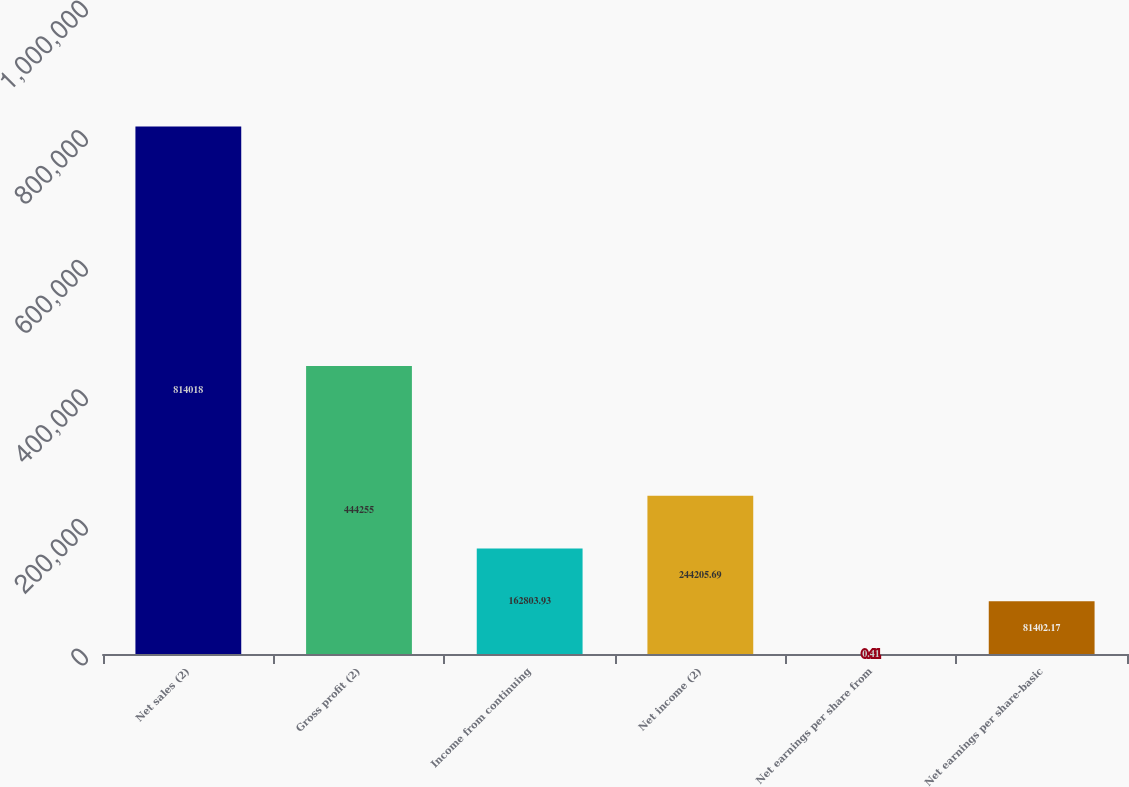Convert chart. <chart><loc_0><loc_0><loc_500><loc_500><bar_chart><fcel>Net sales (2)<fcel>Gross profit (2)<fcel>Income from continuing<fcel>Net income (2)<fcel>Net earnings per share from<fcel>Net earnings per share-basic<nl><fcel>814018<fcel>444255<fcel>162804<fcel>244206<fcel>0.41<fcel>81402.2<nl></chart> 